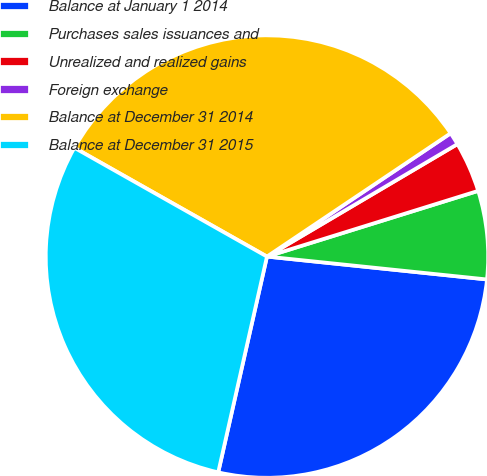<chart> <loc_0><loc_0><loc_500><loc_500><pie_chart><fcel>Balance at January 1 2014<fcel>Purchases sales issuances and<fcel>Unrealized and realized gains<fcel>Foreign exchange<fcel>Balance at December 31 2014<fcel>Balance at December 31 2015<nl><fcel>26.89%<fcel>6.45%<fcel>3.69%<fcel>0.92%<fcel>32.41%<fcel>29.65%<nl></chart> 